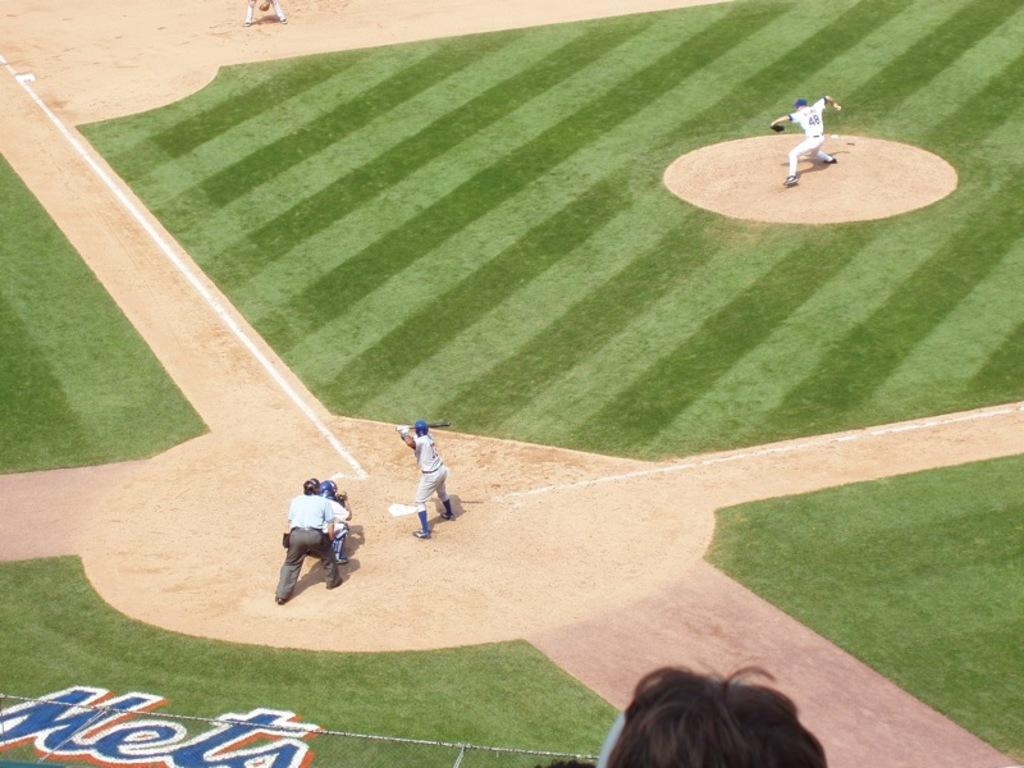How many people are in the image? There are people in the image, but the exact number is not specified. What are the people doing in the image? The people are on the ground, but their specific activity is not mentioned. What object is one person holding in the image? One person is holding a bat in the image. What type of dirt can be seen on the wing of the kettle in the image? There is no kettle or wing present in the image, so it is not possible to determine if there is any dirt on them. 